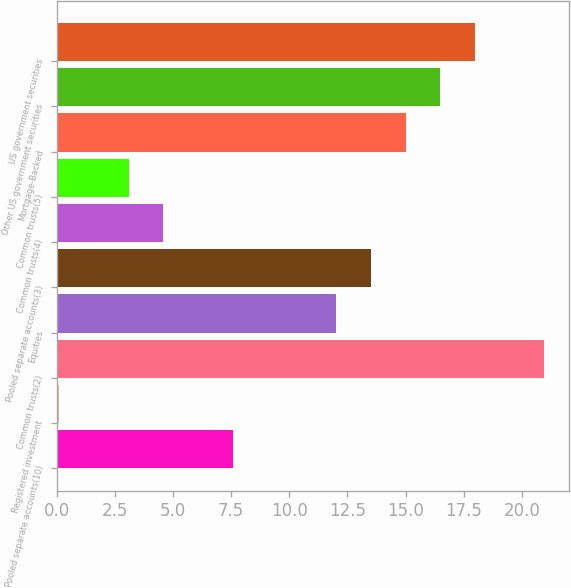Convert chart to OTSL. <chart><loc_0><loc_0><loc_500><loc_500><bar_chart><fcel>Pooled separate accounts(10)<fcel>Registered investment<fcel>Common trusts(2)<fcel>Equities<fcel>Pooled separate accounts(3)<fcel>Common trusts(4)<fcel>Common trusts(5)<fcel>Mortgage-Backed<fcel>Other US government securities<fcel>US government securities<nl><fcel>7.56<fcel>0.11<fcel>20.97<fcel>12.03<fcel>13.52<fcel>4.58<fcel>3.09<fcel>15.01<fcel>16.5<fcel>17.99<nl></chart> 